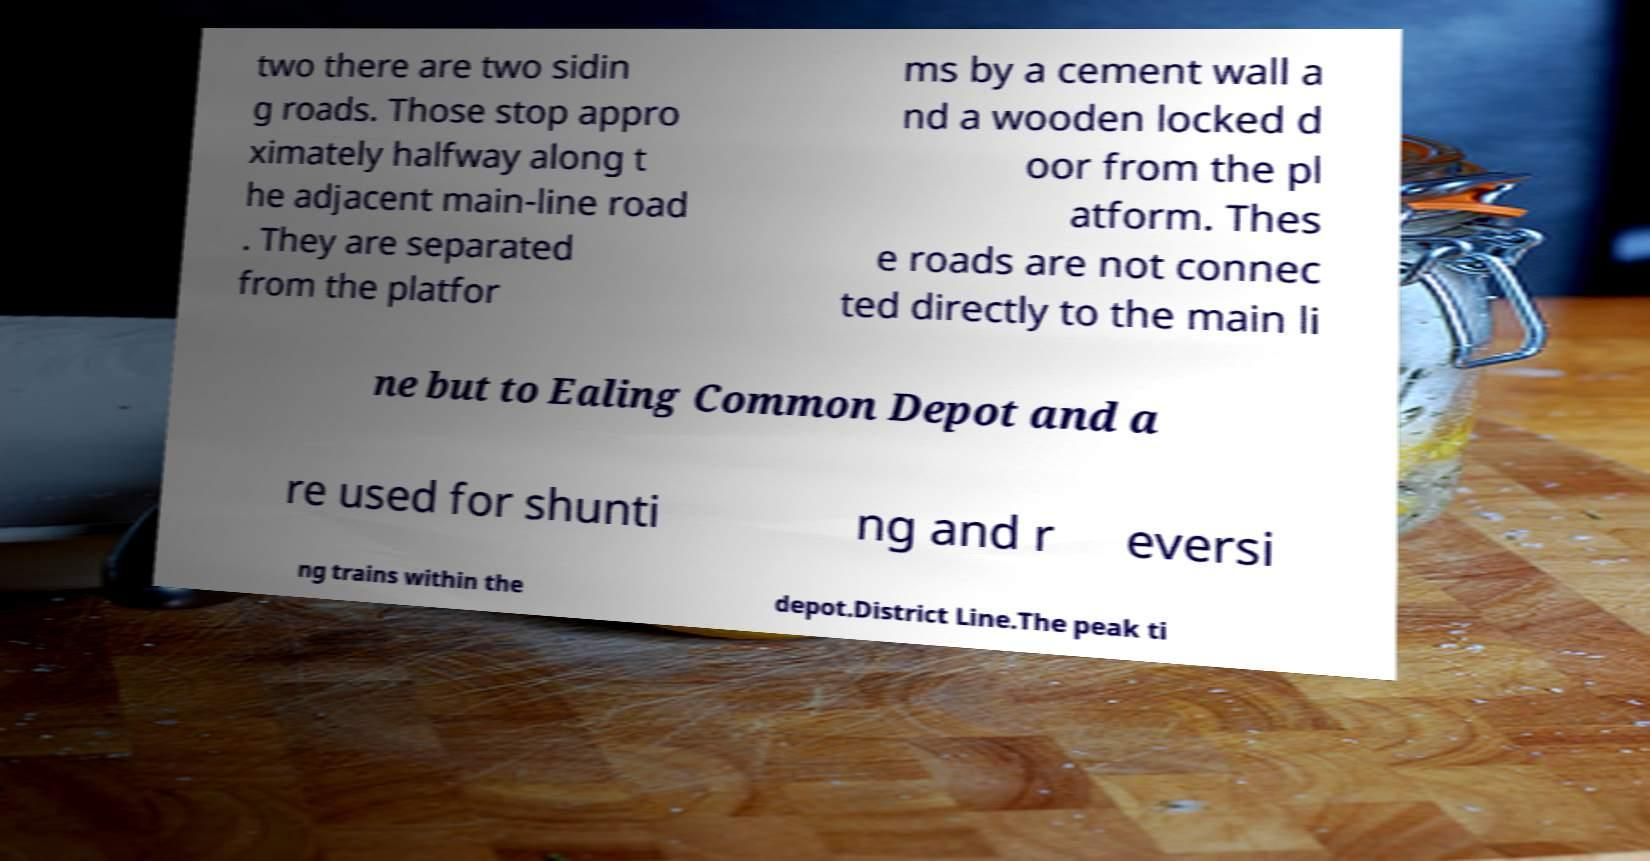What messages or text are displayed in this image? I need them in a readable, typed format. two there are two sidin g roads. Those stop appro ximately halfway along t he adjacent main-line road . They are separated from the platfor ms by a cement wall a nd a wooden locked d oor from the pl atform. Thes e roads are not connec ted directly to the main li ne but to Ealing Common Depot and a re used for shunti ng and r eversi ng trains within the depot.District Line.The peak ti 